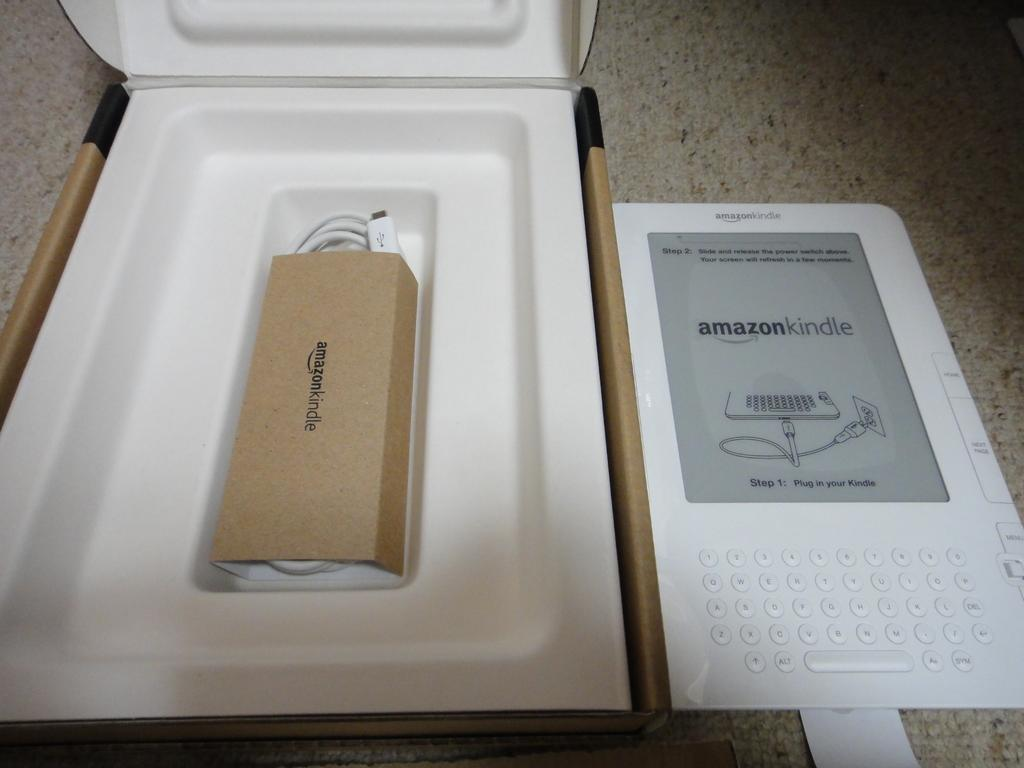<image>
Share a concise interpretation of the image provided. An Amazon Kindle shows Step 2 of setup on its screen and sits next to the box. 